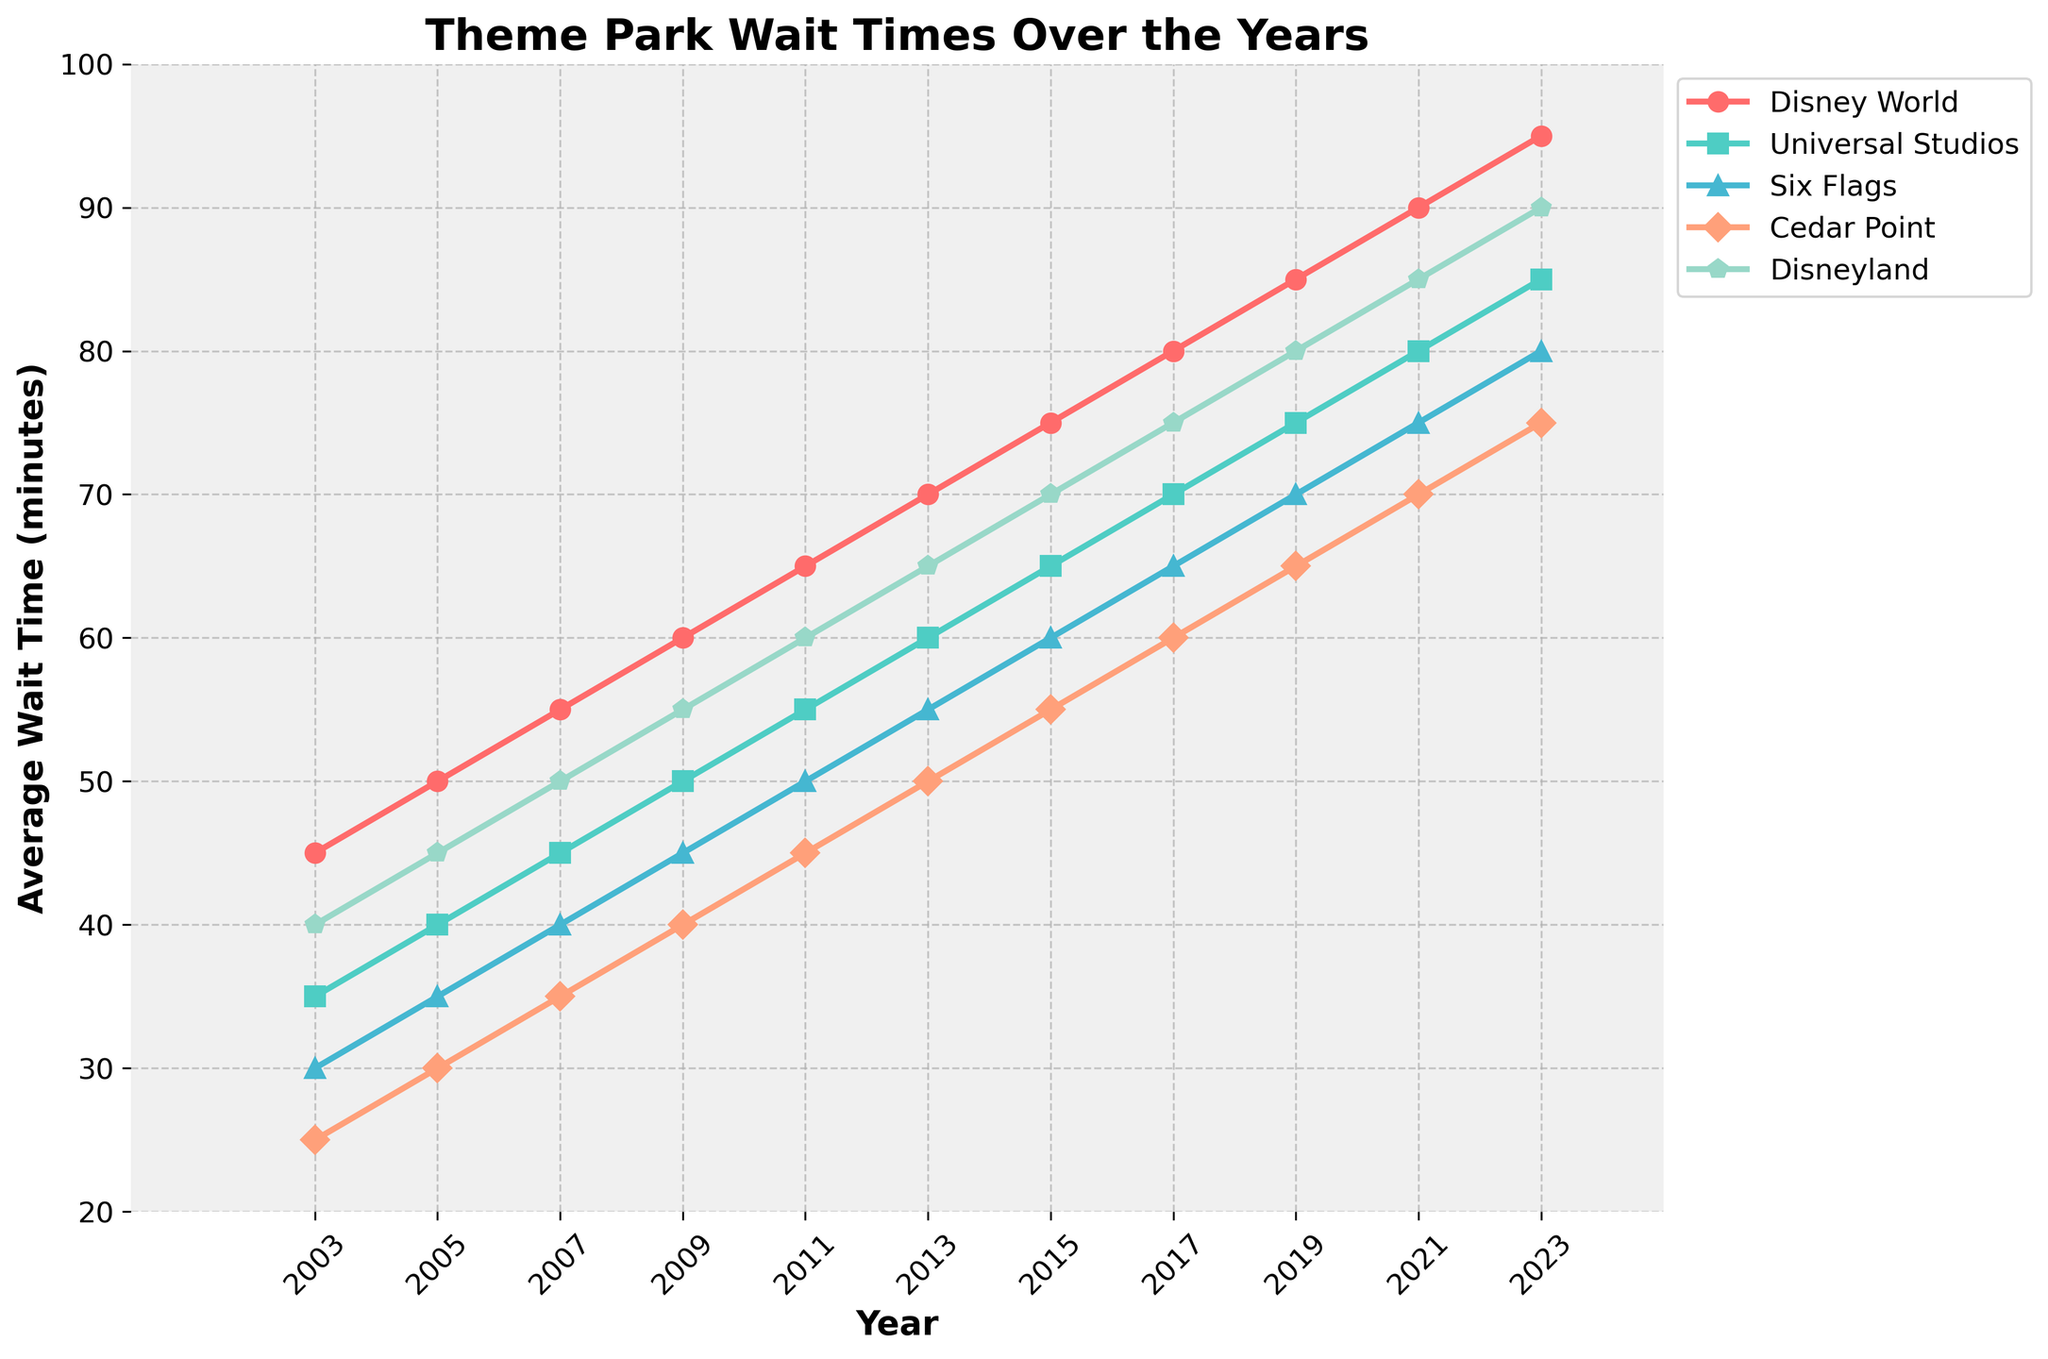What is the comparison of average wait times between Disney World and Universal Studios in 2013? Look at the 2013 data points for Disney World and Universal Studios. Disney World has an average wait time of 70 minutes and Universal Studios has an average wait time of 60 minutes. Thus, Disney World has a 10-minute longer wait.
Answer: Disney World has a 10-minute longer wait Which theme park had the smallest increase in wait times between 2003 and 2023? Calculate the difference in wait times between 2023 and 2003 for each park. Disney World increased by 50 minutes, Universal Studios by 50 minutes, Six Flags by 50 minutes, Cedar Point by 50 minutes, and Disneyland by 50 minutes. Hence, all parks had the same increase.
Answer: All parks had the same increase What was the trend of Cedar Point’s wait times from 2003 to 2023? Check Cedar Point data points from 2003 to 2023: 25, 30, 35, 40, 45, 50, 55, 60, 65, 70, 75. The wait times steadily increased every two years.
Answer: Steadily increased In which year did Disneyland's wait time surpass 60 minutes for the first time? Identify the first data point where Disneyland's wait time exceeds 60 minutes. In 2011, the wait time was 60, and in 2013, it increased to 65. Thus, it surpasses 60 minutes in 2013.
Answer: 2013 By how much did Six Flags wait times increase from 2009 to 2023? Calculate the difference in wait times between 2009 and 2023 for Six Flags. In 2009, the wait time was 45 minutes and in 2023, it is 80 minutes. The increase is 80 - 45 = 35 minutes.
Answer: 35 minutes Which theme park had the highest average wait time in 2017 and what was the value? Look at the 2017 data points and identify the highest number: Disney World (80), Universal Studios (70), Six Flags (65), Cedar Point (60), and Disneyland (75). The highest is Disney World at 80 minutes.
Answer: Disney World, 80 minutes Compare the increase in wait times for Universal Studios and Disneyland from 2005 to 2023. Calculate the differences: Universal Studios (85 - 40 = 45) and Disneyland (90 - 45 = 45). Both parks have an increase of 45 minutes.
Answer: Both 45 minutes 